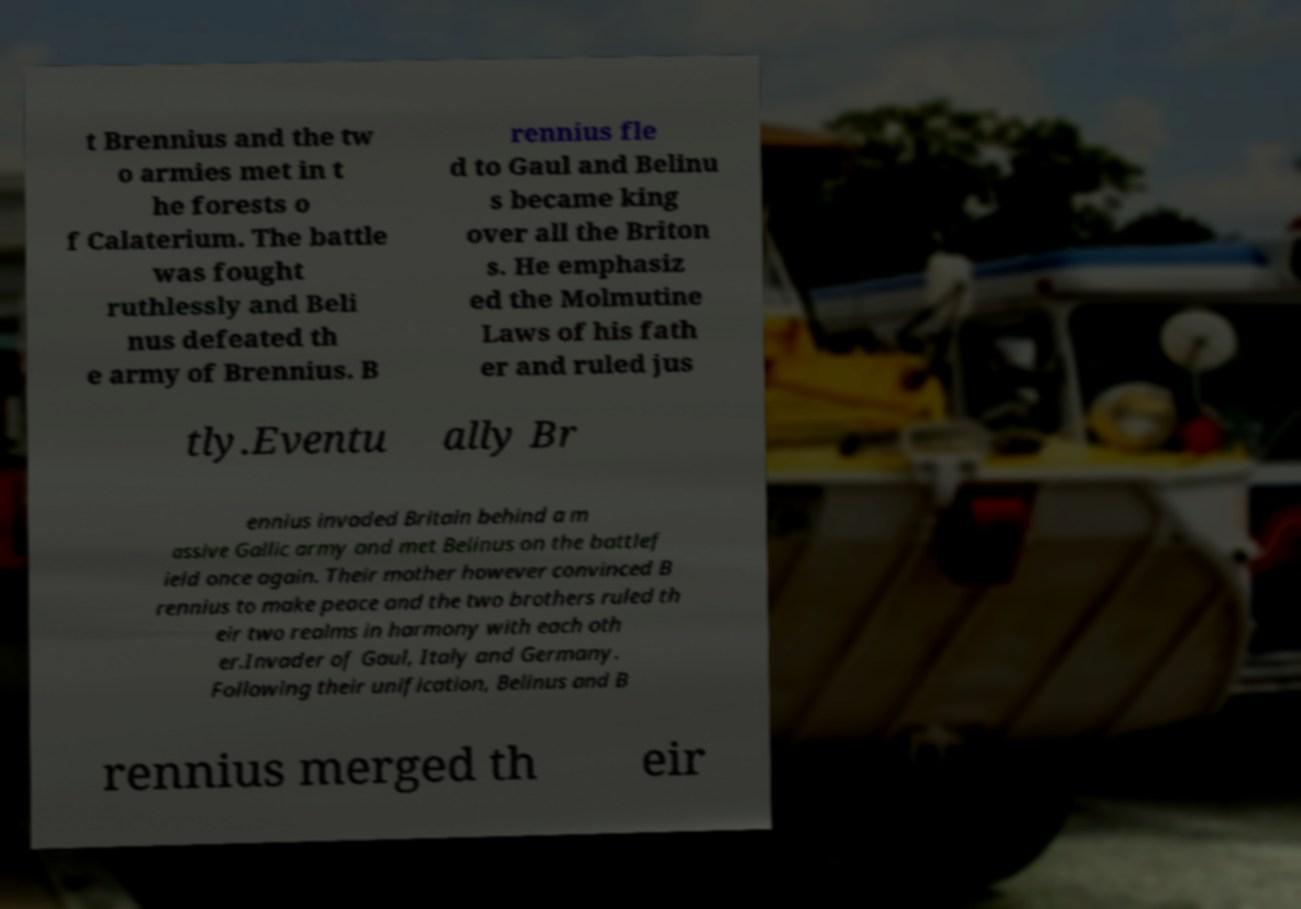What messages or text are displayed in this image? I need them in a readable, typed format. t Brennius and the tw o armies met in t he forests o f Calaterium. The battle was fought ruthlessly and Beli nus defeated th e army of Brennius. B rennius fle d to Gaul and Belinu s became king over all the Briton s. He emphasiz ed the Molmutine Laws of his fath er and ruled jus tly.Eventu ally Br ennius invaded Britain behind a m assive Gallic army and met Belinus on the battlef ield once again. Their mother however convinced B rennius to make peace and the two brothers ruled th eir two realms in harmony with each oth er.Invader of Gaul, Italy and Germany. Following their unification, Belinus and B rennius merged th eir 